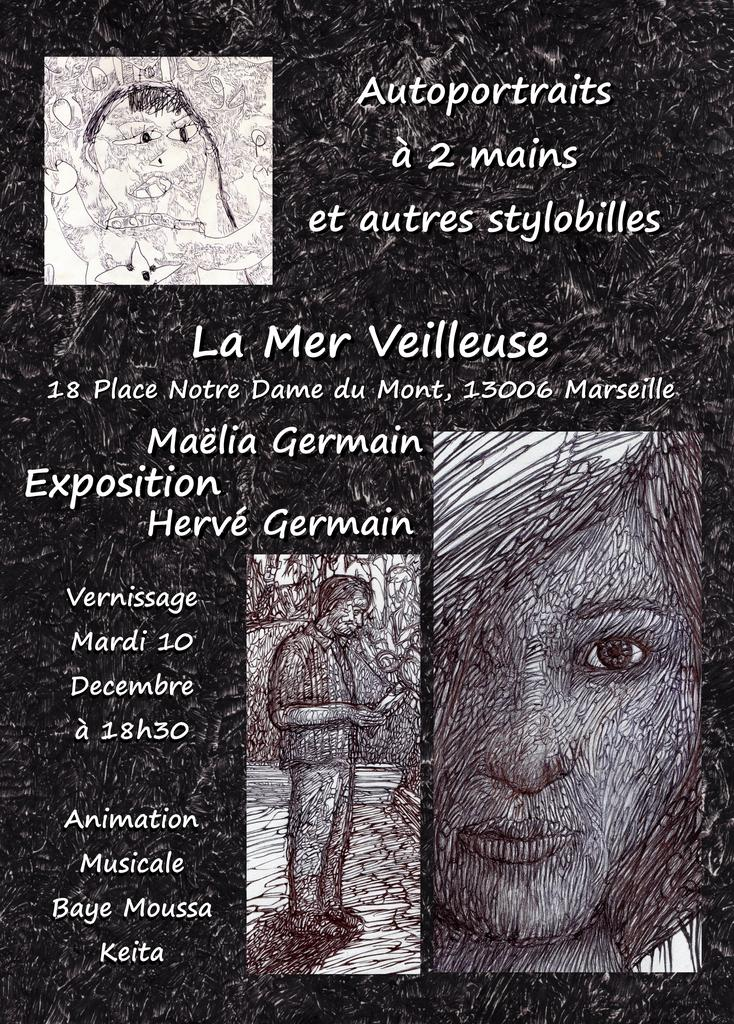What is the main subject of the image? There is an art piece in the image. What is depicted in the art piece? The art piece contains multiple persons. Are there any words or letters in the art piece? Yes, there is text present in the art piece. Can you describe the actions of the person in the art piece? There is a person standing in the art piece, and they are holding an object. What type of sweater is the person wearing in the art piece? There is no sweater present in the art piece; the person is not wearing any clothing. 